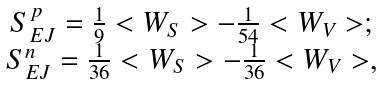<formula> <loc_0><loc_0><loc_500><loc_500>\begin{array} { c l c r } S ^ { p } _ { E J } = \frac { 1 } { 9 } < W _ { S } > - \frac { 1 } { 5 4 } < W _ { V } > ; \\ S ^ { n } _ { E J } = \frac { 1 } { 3 6 } < W _ { S } > - \frac { 1 } { 3 6 } < W _ { V } > , \end{array}</formula> 